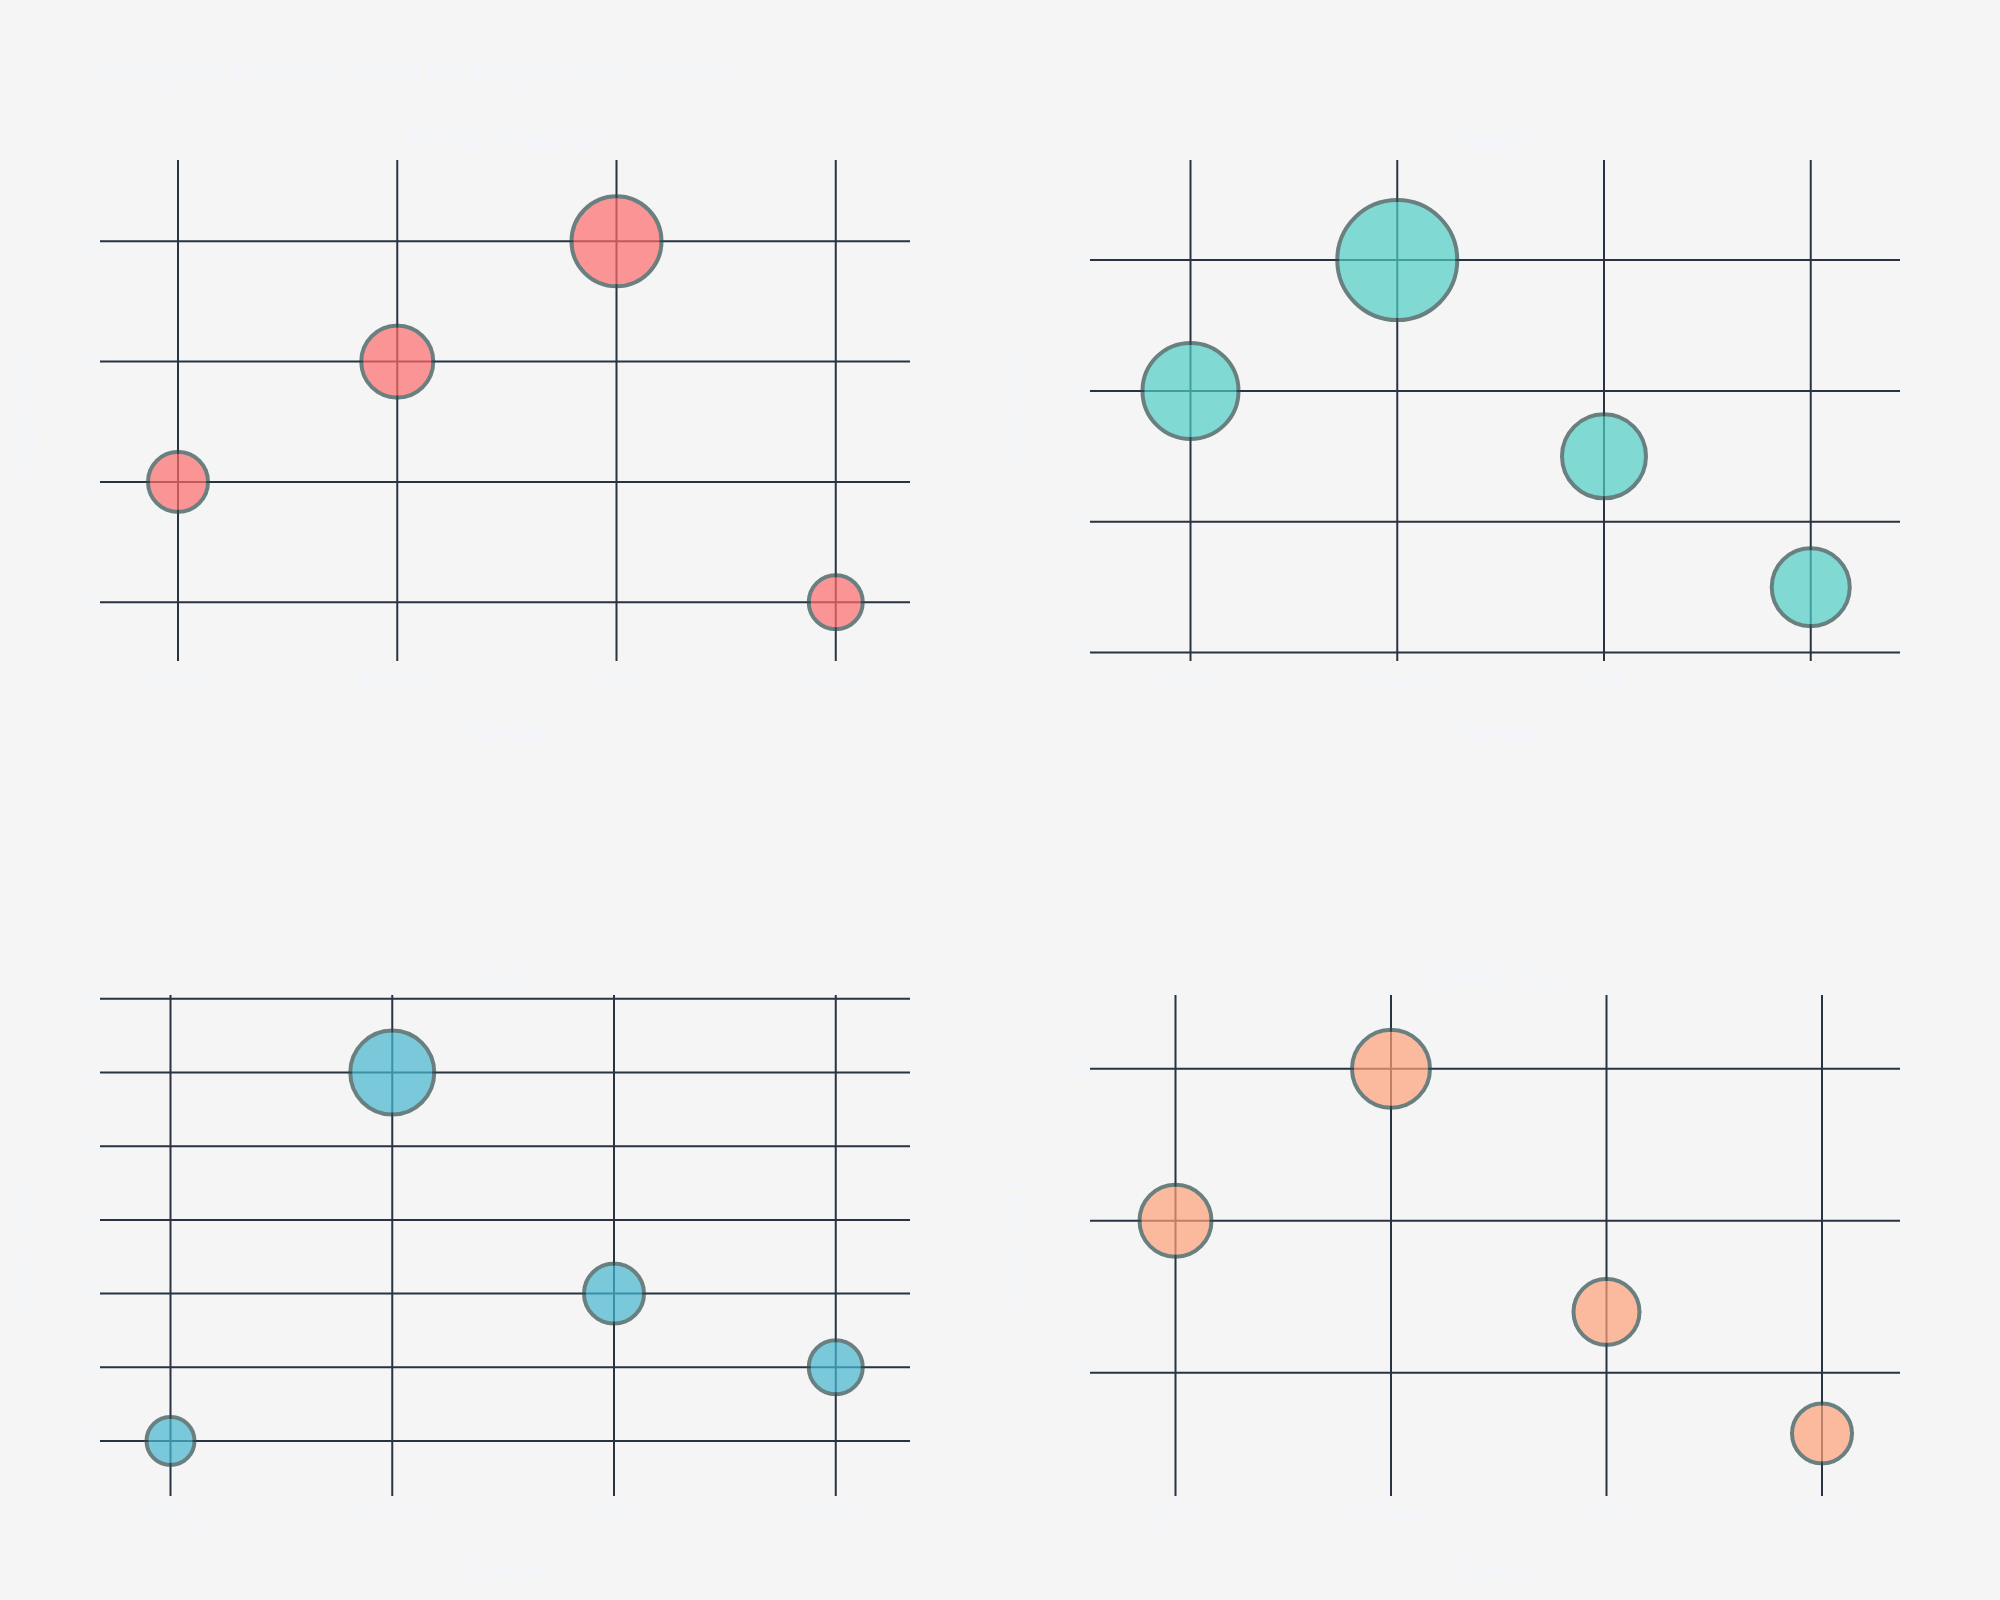How many seasons are represented in the figure? The figure displays one bubble for each season in each region, showing four distinct seasons: Spring, Summer, Fall, and Winter.
Answer: Four Which region shows the highest sales in Summer? By examining the bubble sizes and positions for Summer in each subplot, Europe shows the highest sales with its bubble having a sales value of $80M attributed to Louis Vuitton.
Answer: Europe What is the total sales value for North America across all seasons? Summing the sales values for North America across all bubbles: $50M (Spring) + $55M (Summer) + $60M (Fall) + $45M (Winter) = $210M.
Answer: $210M Which brand has the smallest sales figure in Winter across the regions? By comparing the Winter bubbles' sales figures in each subplot, Burberry in North America and Bottega Veneta in Asia both have $45M.
Answer: Burberry and Bottega Veneta Compare the sales values between Spring and Winter for Europe. Which one is higher and by how much? In the subplot for Europe, the Spring sales (Chanel) are $70M and the Winter sales (Balenciaga) are $55M. The difference is $70M - $55M = $15M, so Spring sales are higher by $15M.
Answer: Spring by $15M Which brand has the smallest bubble size and in which season and region does it appear? The smallest bubble corresponds to the smallest value of Bubble_Size, which is 8. In the Spring season of Asia, Hermès appears with this value.
Answer: Hermès in Asia Spring Is there a region where all four seasons have a relatively uniform sales distribution? Observing the distance between bubbles in each region's subplot, North America shows relatively uniform distribution with sales values ranging from $45M to $60M.
Answer: North America What is the difference in sales between the highest and lowest individual sales figures represented in the chart? The highest individual sales figure is $80M (Louis Vuitton, Europe, Summer) and the lowest is $40M (Hermès, Asia, Spring). The difference is $80M - $40M = $40M.
Answer: $40M Which region shows the least variation in bubble sizes through all seasons? Comparing the range of bubble sizes (sizes: 10-20) in each subplot, the Middle East shows the least variation with sizes ranging from 10 to 13.
Answer: Middle East How many brands are represented across all regions and seasons? Counting the distinct brands mentioned in each bubble's text annotation, there are 16 different brands represented in the figure.
Answer: 16 